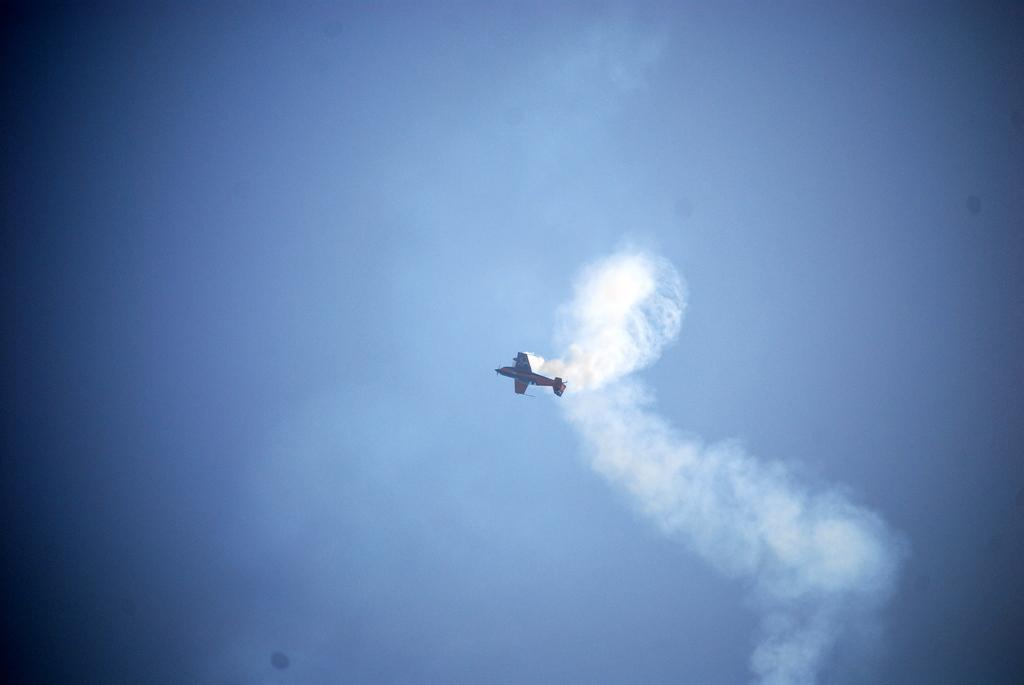What is the main subject of the picture? The main subject of the picture is an airplane. What can be seen in the sky in the image? White smoke is visible in the sky. How many babies are playing with underwear in the image? There are no babies or underwear present in the image; it features an airplane and white smoke in the sky. Are the friends in the image wearing matching outfits? There are no friends or outfits mentioned in the image, as it only features an airplane and white smoke in the sky. 